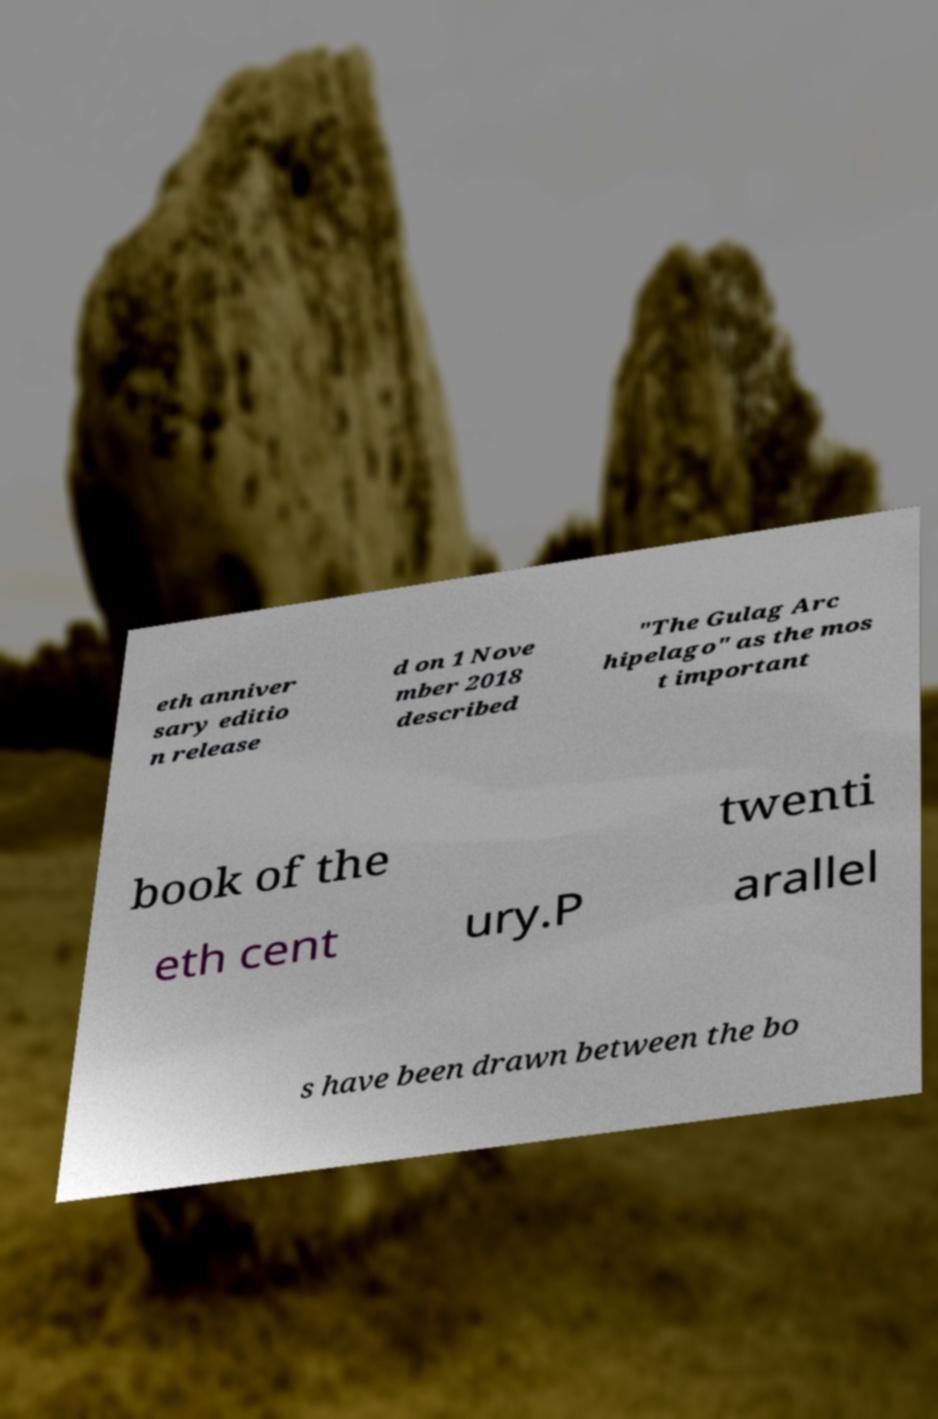I need the written content from this picture converted into text. Can you do that? eth anniver sary editio n release d on 1 Nove mber 2018 described "The Gulag Arc hipelago" as the mos t important book of the twenti eth cent ury.P arallel s have been drawn between the bo 